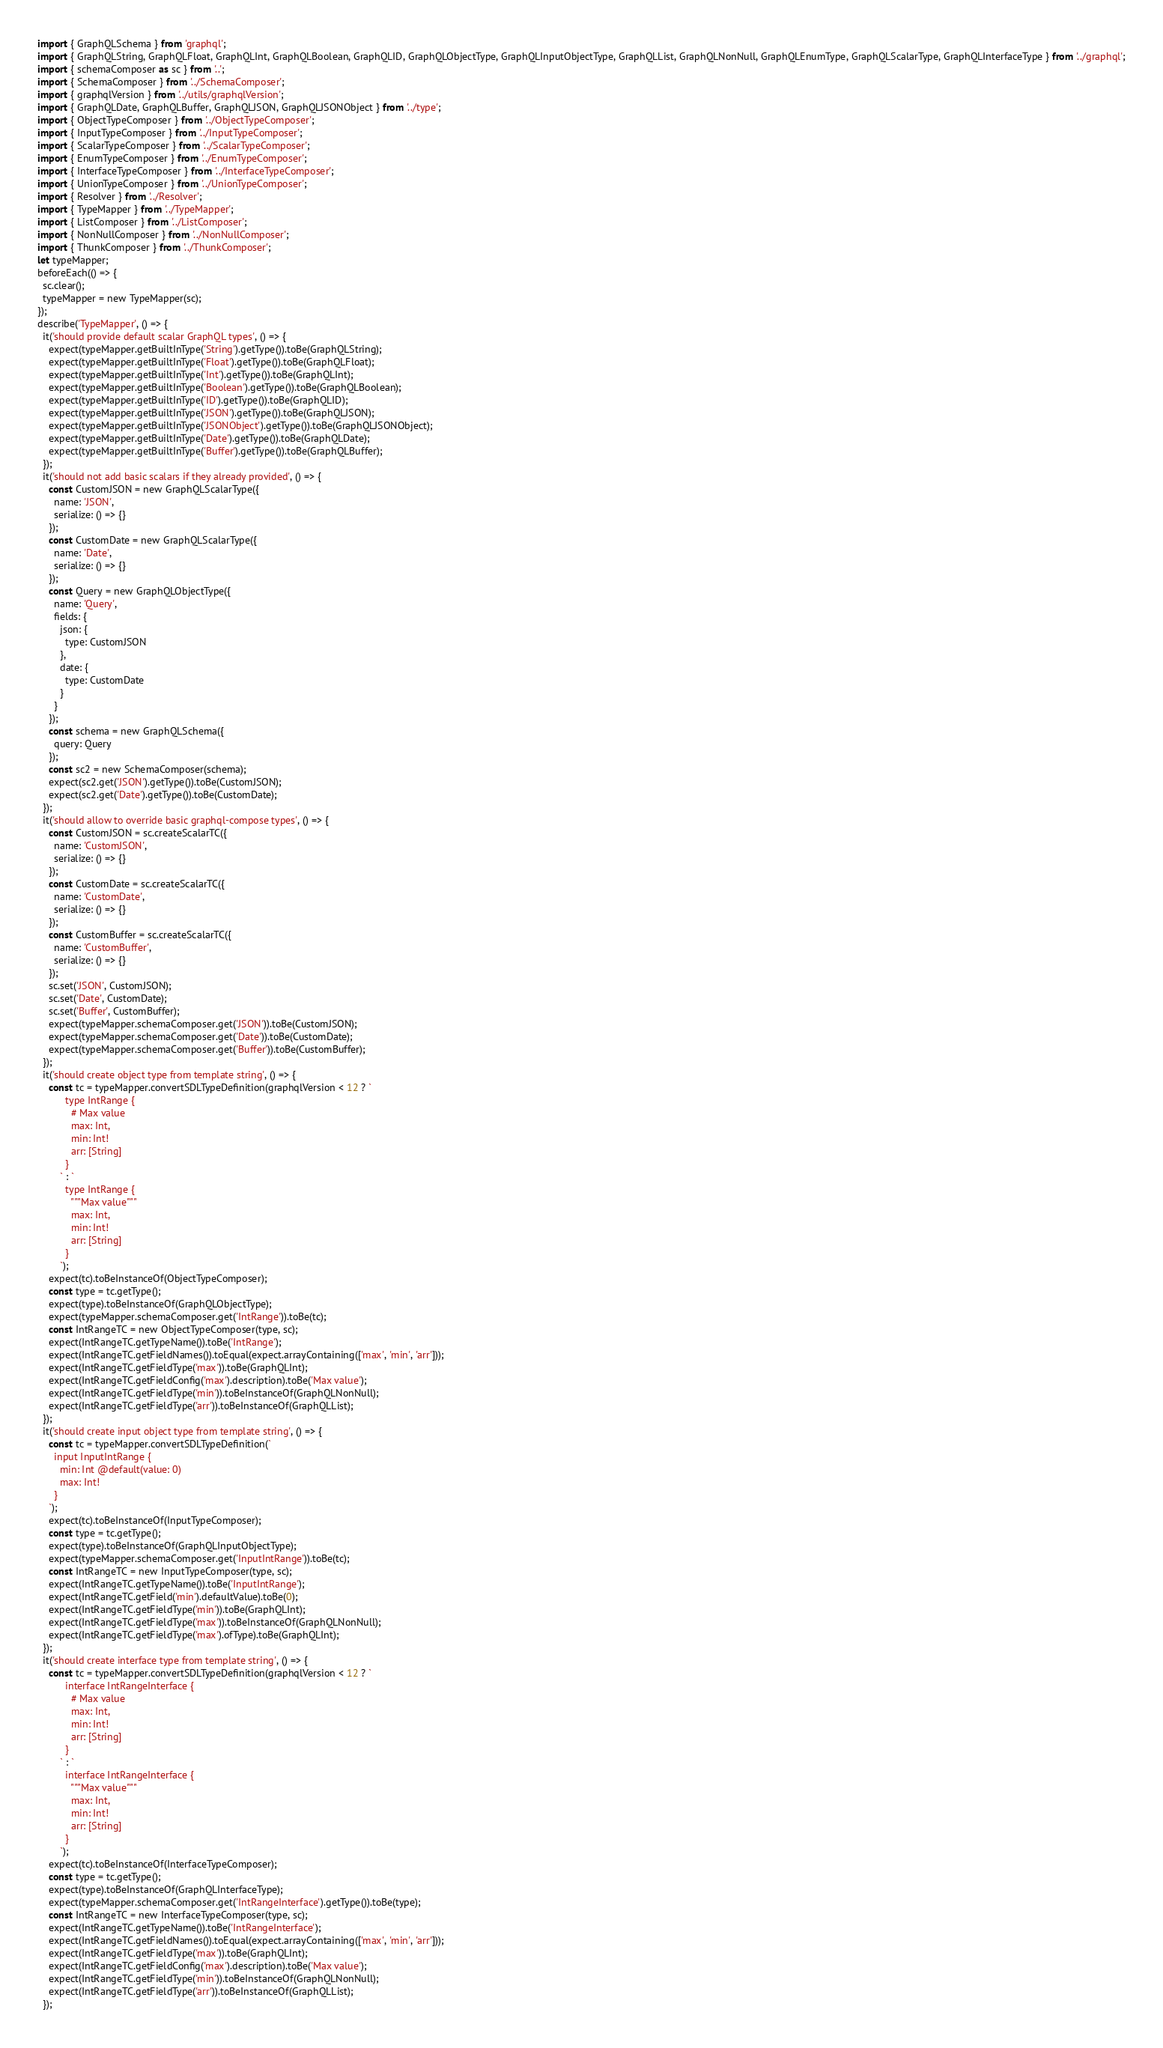Convert code to text. <code><loc_0><loc_0><loc_500><loc_500><_JavaScript_>import { GraphQLSchema } from 'graphql';
import { GraphQLString, GraphQLFloat, GraphQLInt, GraphQLBoolean, GraphQLID, GraphQLObjectType, GraphQLInputObjectType, GraphQLList, GraphQLNonNull, GraphQLEnumType, GraphQLScalarType, GraphQLInterfaceType } from '../graphql';
import { schemaComposer as sc } from '..';
import { SchemaComposer } from '../SchemaComposer';
import { graphqlVersion } from '../utils/graphqlVersion';
import { GraphQLDate, GraphQLBuffer, GraphQLJSON, GraphQLJSONObject } from '../type';
import { ObjectTypeComposer } from '../ObjectTypeComposer';
import { InputTypeComposer } from '../InputTypeComposer';
import { ScalarTypeComposer } from '../ScalarTypeComposer';
import { EnumTypeComposer } from '../EnumTypeComposer';
import { InterfaceTypeComposer } from '../InterfaceTypeComposer';
import { UnionTypeComposer } from '../UnionTypeComposer';
import { Resolver } from '../Resolver';
import { TypeMapper } from '../TypeMapper';
import { ListComposer } from '../ListComposer';
import { NonNullComposer } from '../NonNullComposer';
import { ThunkComposer } from '../ThunkComposer';
let typeMapper;
beforeEach(() => {
  sc.clear();
  typeMapper = new TypeMapper(sc);
});
describe('TypeMapper', () => {
  it('should provide default scalar GraphQL types', () => {
    expect(typeMapper.getBuiltInType('String').getType()).toBe(GraphQLString);
    expect(typeMapper.getBuiltInType('Float').getType()).toBe(GraphQLFloat);
    expect(typeMapper.getBuiltInType('Int').getType()).toBe(GraphQLInt);
    expect(typeMapper.getBuiltInType('Boolean').getType()).toBe(GraphQLBoolean);
    expect(typeMapper.getBuiltInType('ID').getType()).toBe(GraphQLID);
    expect(typeMapper.getBuiltInType('JSON').getType()).toBe(GraphQLJSON);
    expect(typeMapper.getBuiltInType('JSONObject').getType()).toBe(GraphQLJSONObject);
    expect(typeMapper.getBuiltInType('Date').getType()).toBe(GraphQLDate);
    expect(typeMapper.getBuiltInType('Buffer').getType()).toBe(GraphQLBuffer);
  });
  it('should not add basic scalars if they already provided', () => {
    const CustomJSON = new GraphQLScalarType({
      name: 'JSON',
      serialize: () => {}
    });
    const CustomDate = new GraphQLScalarType({
      name: 'Date',
      serialize: () => {}
    });
    const Query = new GraphQLObjectType({
      name: 'Query',
      fields: {
        json: {
          type: CustomJSON
        },
        date: {
          type: CustomDate
        }
      }
    });
    const schema = new GraphQLSchema({
      query: Query
    });
    const sc2 = new SchemaComposer(schema);
    expect(sc2.get('JSON').getType()).toBe(CustomJSON);
    expect(sc2.get('Date').getType()).toBe(CustomDate);
  });
  it('should allow to override basic graphql-compose types', () => {
    const CustomJSON = sc.createScalarTC({
      name: 'CustomJSON',
      serialize: () => {}
    });
    const CustomDate = sc.createScalarTC({
      name: 'CustomDate',
      serialize: () => {}
    });
    const CustomBuffer = sc.createScalarTC({
      name: 'CustomBuffer',
      serialize: () => {}
    });
    sc.set('JSON', CustomJSON);
    sc.set('Date', CustomDate);
    sc.set('Buffer', CustomBuffer);
    expect(typeMapper.schemaComposer.get('JSON')).toBe(CustomJSON);
    expect(typeMapper.schemaComposer.get('Date')).toBe(CustomDate);
    expect(typeMapper.schemaComposer.get('Buffer')).toBe(CustomBuffer);
  });
  it('should create object type from template string', () => {
    const tc = typeMapper.convertSDLTypeDefinition(graphqlVersion < 12 ? `
          type IntRange {
            # Max value
            max: Int,
            min: Int!
            arr: [String]
          }
        ` : `
          type IntRange {
            """Max value"""
            max: Int,
            min: Int!
            arr: [String]
          }
        `);
    expect(tc).toBeInstanceOf(ObjectTypeComposer);
    const type = tc.getType();
    expect(type).toBeInstanceOf(GraphQLObjectType);
    expect(typeMapper.schemaComposer.get('IntRange')).toBe(tc);
    const IntRangeTC = new ObjectTypeComposer(type, sc);
    expect(IntRangeTC.getTypeName()).toBe('IntRange');
    expect(IntRangeTC.getFieldNames()).toEqual(expect.arrayContaining(['max', 'min', 'arr']));
    expect(IntRangeTC.getFieldType('max')).toBe(GraphQLInt);
    expect(IntRangeTC.getFieldConfig('max').description).toBe('Max value');
    expect(IntRangeTC.getFieldType('min')).toBeInstanceOf(GraphQLNonNull);
    expect(IntRangeTC.getFieldType('arr')).toBeInstanceOf(GraphQLList);
  });
  it('should create input object type from template string', () => {
    const tc = typeMapper.convertSDLTypeDefinition(`
      input InputIntRange {
        min: Int @default(value: 0)
        max: Int!
      }
    `);
    expect(tc).toBeInstanceOf(InputTypeComposer);
    const type = tc.getType();
    expect(type).toBeInstanceOf(GraphQLInputObjectType);
    expect(typeMapper.schemaComposer.get('InputIntRange')).toBe(tc);
    const IntRangeTC = new InputTypeComposer(type, sc);
    expect(IntRangeTC.getTypeName()).toBe('InputIntRange');
    expect(IntRangeTC.getField('min').defaultValue).toBe(0);
    expect(IntRangeTC.getFieldType('min')).toBe(GraphQLInt);
    expect(IntRangeTC.getFieldType('max')).toBeInstanceOf(GraphQLNonNull);
    expect(IntRangeTC.getFieldType('max').ofType).toBe(GraphQLInt);
  });
  it('should create interface type from template string', () => {
    const tc = typeMapper.convertSDLTypeDefinition(graphqlVersion < 12 ? `
          interface IntRangeInterface {
            # Max value
            max: Int,
            min: Int!
            arr: [String]
          }
        ` : `
          interface IntRangeInterface {
            """Max value"""
            max: Int,
            min: Int!
            arr: [String]
          }
        `);
    expect(tc).toBeInstanceOf(InterfaceTypeComposer);
    const type = tc.getType();
    expect(type).toBeInstanceOf(GraphQLInterfaceType);
    expect(typeMapper.schemaComposer.get('IntRangeInterface').getType()).toBe(type);
    const IntRangeTC = new InterfaceTypeComposer(type, sc);
    expect(IntRangeTC.getTypeName()).toBe('IntRangeInterface');
    expect(IntRangeTC.getFieldNames()).toEqual(expect.arrayContaining(['max', 'min', 'arr']));
    expect(IntRangeTC.getFieldType('max')).toBe(GraphQLInt);
    expect(IntRangeTC.getFieldConfig('max').description).toBe('Max value');
    expect(IntRangeTC.getFieldType('min')).toBeInstanceOf(GraphQLNonNull);
    expect(IntRangeTC.getFieldType('arr')).toBeInstanceOf(GraphQLList);
  });</code> 